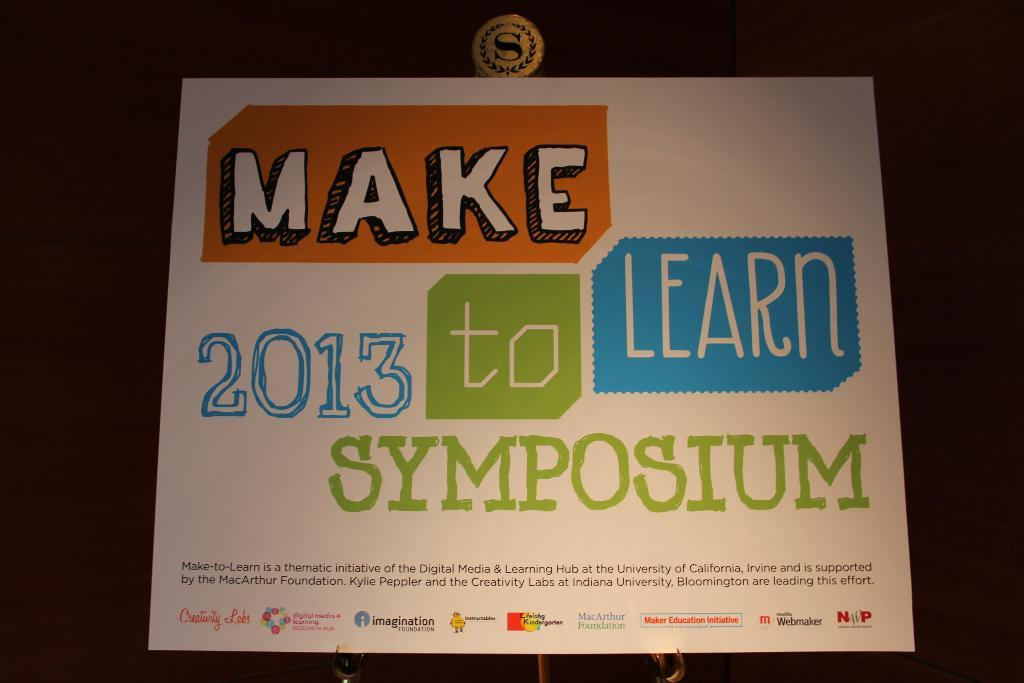<image>
Create a compact narrative representing the image presented. Make 2013 to learn Symposium paper from the University of California 